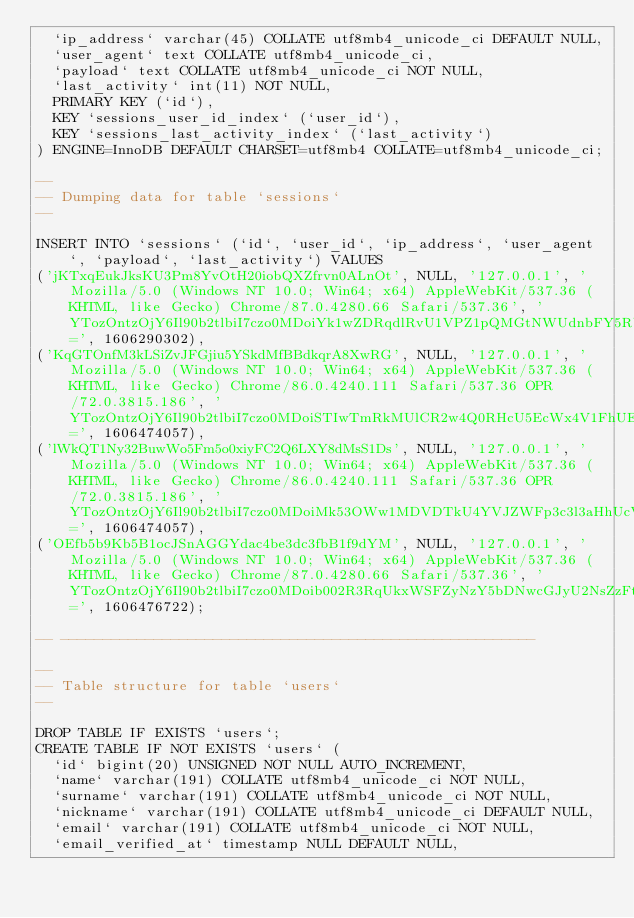Convert code to text. <code><loc_0><loc_0><loc_500><loc_500><_SQL_>  `ip_address` varchar(45) COLLATE utf8mb4_unicode_ci DEFAULT NULL,
  `user_agent` text COLLATE utf8mb4_unicode_ci,
  `payload` text COLLATE utf8mb4_unicode_ci NOT NULL,
  `last_activity` int(11) NOT NULL,
  PRIMARY KEY (`id`),
  KEY `sessions_user_id_index` (`user_id`),
  KEY `sessions_last_activity_index` (`last_activity`)
) ENGINE=InnoDB DEFAULT CHARSET=utf8mb4 COLLATE=utf8mb4_unicode_ci;

--
-- Dumping data for table `sessions`
--

INSERT INTO `sessions` (`id`, `user_id`, `ip_address`, `user_agent`, `payload`, `last_activity`) VALUES
('jKTxqEukJksKU3Pm8YvOtH20iobQXZfrvn0ALnOt', NULL, '127.0.0.1', 'Mozilla/5.0 (Windows NT 10.0; Win64; x64) AppleWebKit/537.36 (KHTML, like Gecko) Chrome/87.0.4280.66 Safari/537.36', 'YTozOntzOjY6Il90b2tlbiI7czo0MDoiYk1wZDRqdlRvU1VPZ1pQMGtNWUdnbFY5RUdMdjRkRXhhV1lhcWFJZiI7czo5OiJfcHJldmlvdXMiO2E6MTp7czozOiJ1cmwiO3M6Mjc6Imh0dHA6Ly8xMjcuMC4wLjE6ODAwMC9sb2dpbiI7fXM6NjoiX2ZsYXNoIjthOjI6e3M6Mzoib2xkIjthOjA6e31zOjM6Im5ldyI7YTowOnt9fX0=', 1606290302),
('KqGTOnfM3kLSiZvJFGjiu5YSkdMfBBdkqrA8XwRG', NULL, '127.0.0.1', 'Mozilla/5.0 (Windows NT 10.0; Win64; x64) AppleWebKit/537.36 (KHTML, like Gecko) Chrome/86.0.4240.111 Safari/537.36 OPR/72.0.3815.186', 'YTozOntzOjY6Il90b2tlbiI7czo0MDoiSTIwTmRkMUlCR2w4Q0RHcU5EcWx4V1FhUEdmMmNJYjdiQUtVZVNJNSI7czo5OiJfcHJldmlvdXMiO2E6MTp7czozOiJ1cmwiO3M6MzA6Imh0dHA6Ly8zNjc3LWJhY2tlbmQvc2VydmVyLnBocCI7fXM6NjoiX2ZsYXNoIjthOjI6e3M6Mzoib2xkIjthOjA6e31zOjM6Im5ldyI7YTowOnt9fX0=', 1606474057),
('lWkQT1Ny32BuwWo5Fm5o0xiyFC2Q6LXY8dMsS1Ds', NULL, '127.0.0.1', 'Mozilla/5.0 (Windows NT 10.0; Win64; x64) AppleWebKit/537.36 (KHTML, like Gecko) Chrome/86.0.4240.111 Safari/537.36 OPR/72.0.3815.186', 'YTozOntzOjY6Il90b2tlbiI7czo0MDoiMk53OWw1MDVDTkU4YVJZWFp3c3l3aHhUcVI0M3N4YzlPMmluMFJ5dCI7czo5OiJfcHJldmlvdXMiO2E6MTp7czozOiJ1cmwiO3M6MzA6Imh0dHA6Ly8zNjc3LWJhY2tlbmQvc2VydmVyLnBocCI7fXM6NjoiX2ZsYXNoIjthOjI6e3M6Mzoib2xkIjthOjA6e31zOjM6Im5ldyI7YTowOnt9fX0=', 1606474057),
('OEfb5b9Kb5B1ocJSnAGGYdac4be3dc3fbB1f9dYM', NULL, '127.0.0.1', 'Mozilla/5.0 (Windows NT 10.0; Win64; x64) AppleWebKit/537.36 (KHTML, like Gecko) Chrome/87.0.4280.66 Safari/537.36', 'YTozOntzOjY6Il90b2tlbiI7czo0MDoib002R3RqUkxWSFZyNzY5bDNwcGJyU2NsZzFtQnpacVNoMU1aM1ZHWCI7czo5OiJfcHJldmlvdXMiO2E6MTp7czozOiJ1cmwiO3M6MjE6Imh0dHA6Ly8xMjcuMC4wLjE6ODAwMCI7fXM6NjoiX2ZsYXNoIjthOjI6e3M6Mzoib2xkIjthOjA6e31zOjM6Im5ldyI7YTowOnt9fX0=', 1606476722);

-- --------------------------------------------------------

--
-- Table structure for table `users`
--

DROP TABLE IF EXISTS `users`;
CREATE TABLE IF NOT EXISTS `users` (
  `id` bigint(20) UNSIGNED NOT NULL AUTO_INCREMENT,
  `name` varchar(191) COLLATE utf8mb4_unicode_ci NOT NULL,
  `surname` varchar(191) COLLATE utf8mb4_unicode_ci NOT NULL,
  `nickname` varchar(191) COLLATE utf8mb4_unicode_ci DEFAULT NULL,
  `email` varchar(191) COLLATE utf8mb4_unicode_ci NOT NULL,
  `email_verified_at` timestamp NULL DEFAULT NULL,</code> 